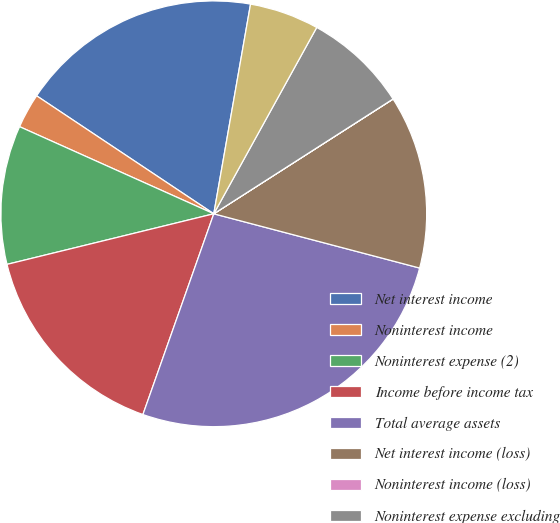Convert chart. <chart><loc_0><loc_0><loc_500><loc_500><pie_chart><fcel>Net interest income<fcel>Noninterest income<fcel>Noninterest expense (2)<fcel>Income before income tax<fcel>Total average assets<fcel>Net interest income (loss)<fcel>Noninterest income (loss)<fcel>Noninterest expense excluding<fcel>Income (loss) before income<nl><fcel>18.41%<fcel>2.64%<fcel>10.53%<fcel>15.78%<fcel>26.3%<fcel>13.16%<fcel>0.01%<fcel>7.9%<fcel>5.27%<nl></chart> 